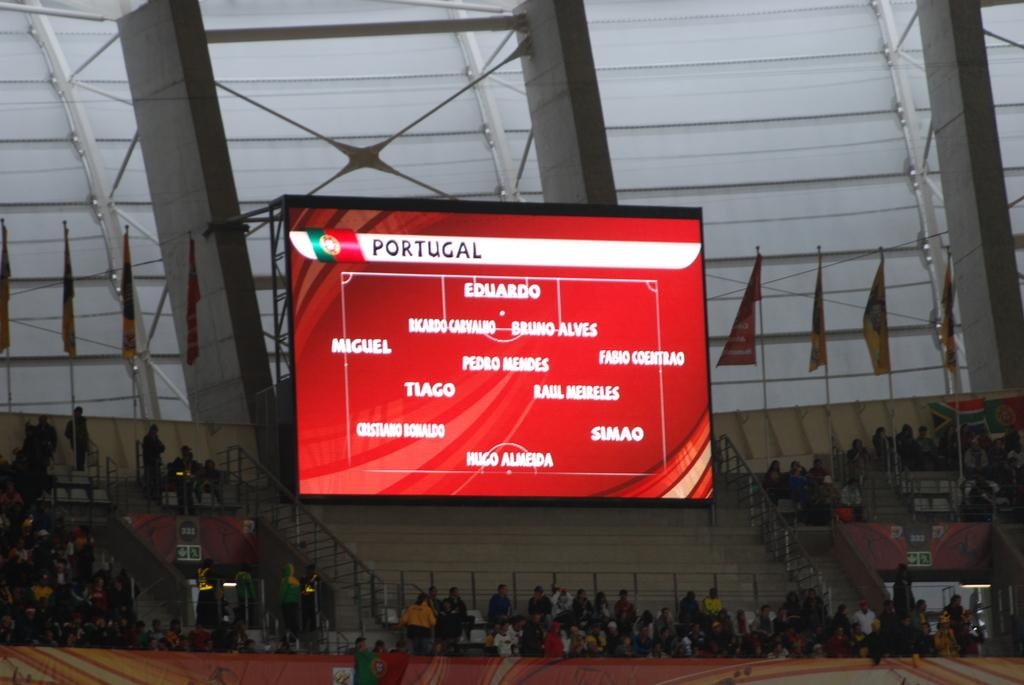Provide a one-sentence caption for the provided image. Portugal has eleven members participating for their team. 